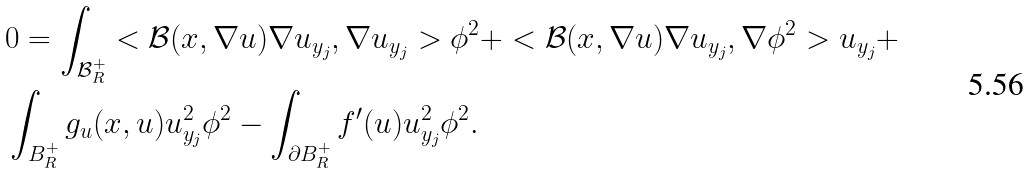Convert formula to latex. <formula><loc_0><loc_0><loc_500><loc_500>& 0 = \int _ { \mathcal { B } _ { R } ^ { + } } < \mathcal { B } ( x , \nabla u ) \nabla u _ { y _ { j } } , \nabla u _ { y _ { j } } > \phi ^ { 2 } + < \mathcal { B } ( x , \nabla u ) \nabla u _ { y _ { j } } , \nabla \phi ^ { 2 } > u _ { y _ { j } } + \\ & \int _ { B _ { R } ^ { + } } g _ { u } ( x , u ) u _ { y _ { j } } ^ { 2 } \phi ^ { 2 } - \int _ { \partial B _ { R } ^ { + } } f ^ { \prime } ( u ) u _ { y _ { j } } ^ { 2 } \phi ^ { 2 } .</formula> 